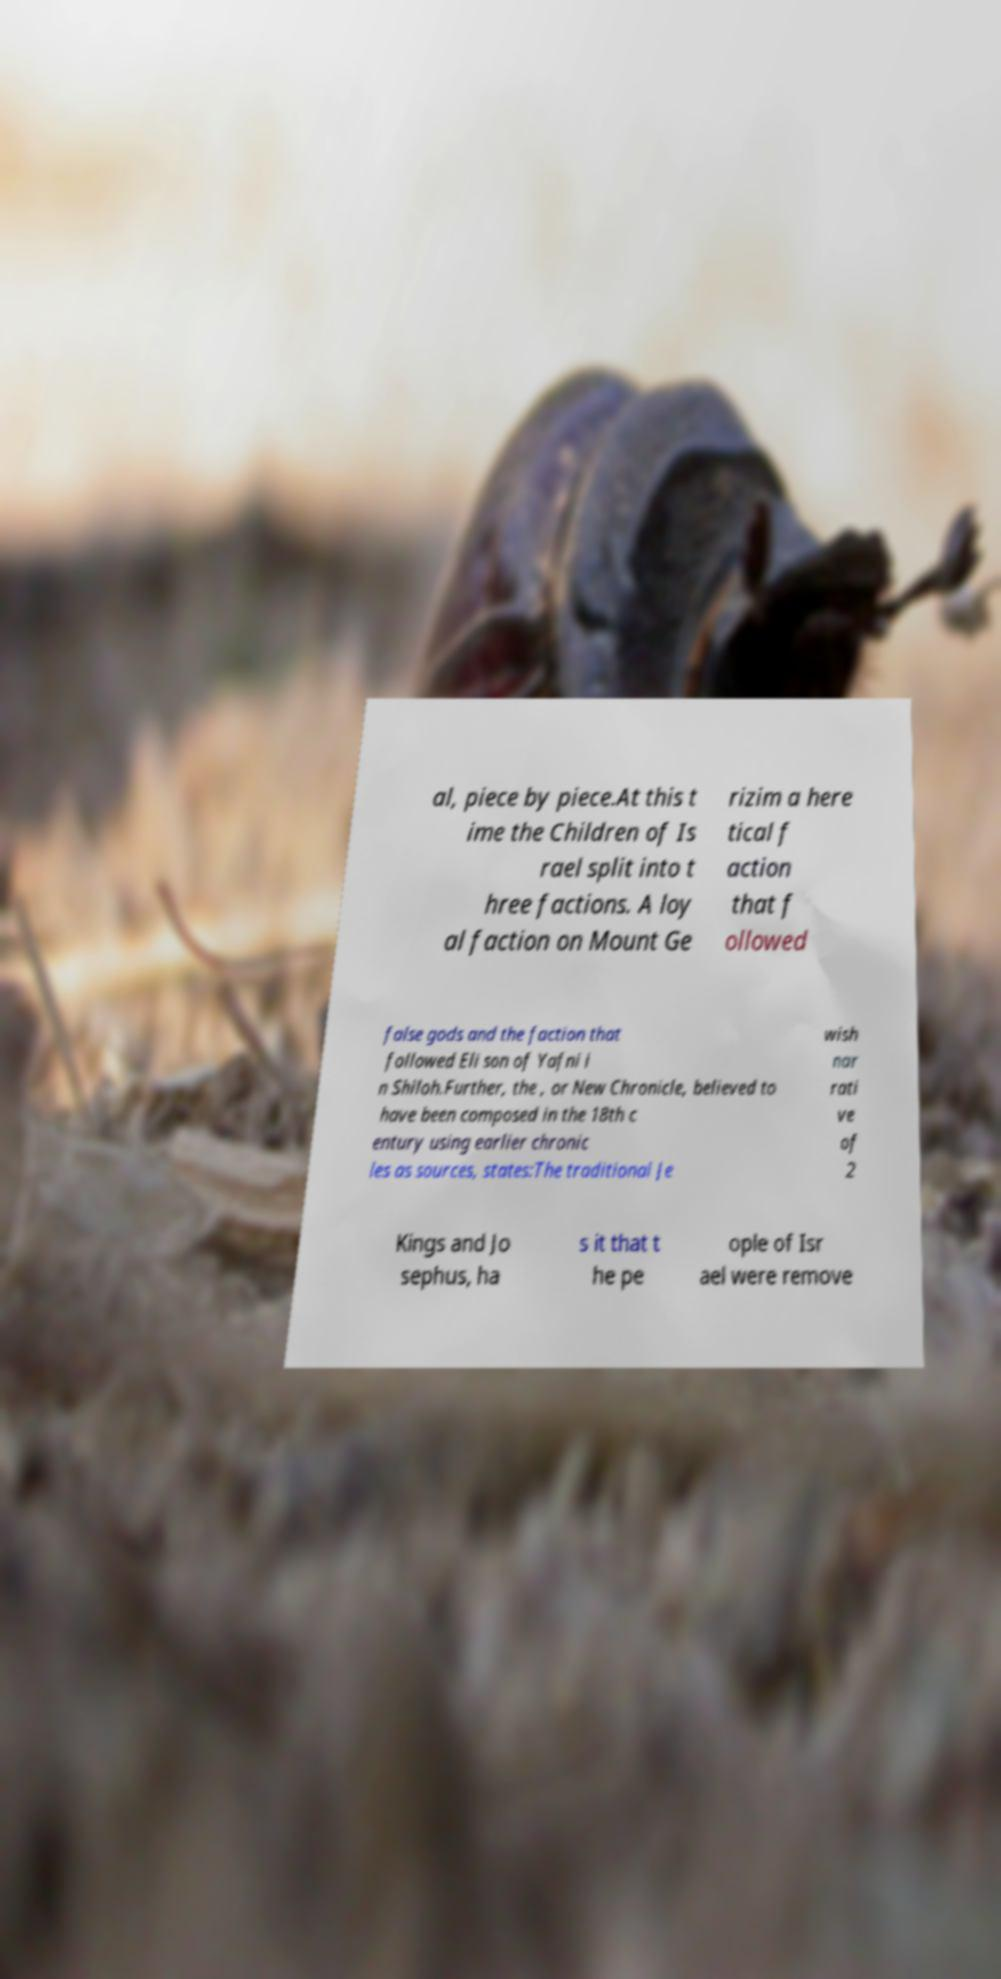Could you assist in decoding the text presented in this image and type it out clearly? al, piece by piece.At this t ime the Children of Is rael split into t hree factions. A loy al faction on Mount Ge rizim a here tical f action that f ollowed false gods and the faction that followed Eli son of Yafni i n Shiloh.Further, the , or New Chronicle, believed to have been composed in the 18th c entury using earlier chronic les as sources, states:The traditional Je wish nar rati ve of 2 Kings and Jo sephus, ha s it that t he pe ople of Isr ael were remove 